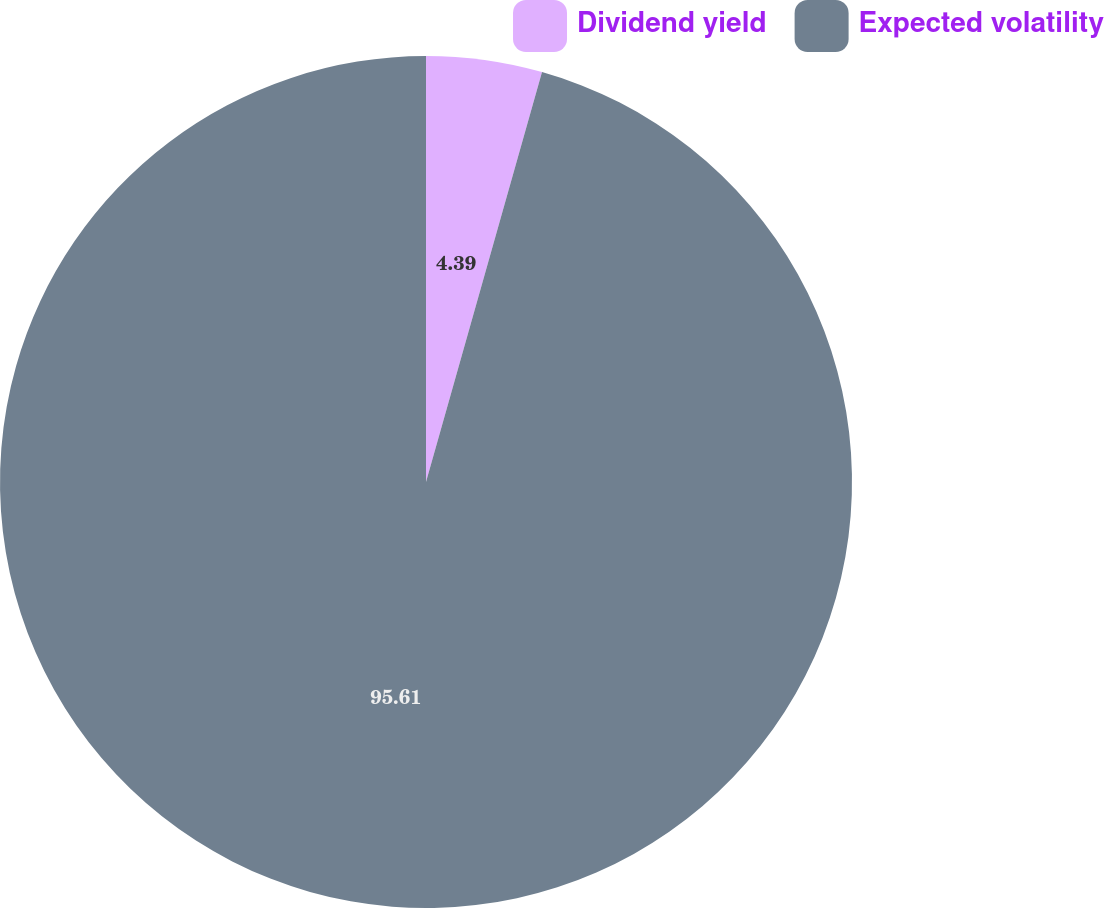Convert chart to OTSL. <chart><loc_0><loc_0><loc_500><loc_500><pie_chart><fcel>Dividend yield<fcel>Expected volatility<nl><fcel>4.39%<fcel>95.61%<nl></chart> 